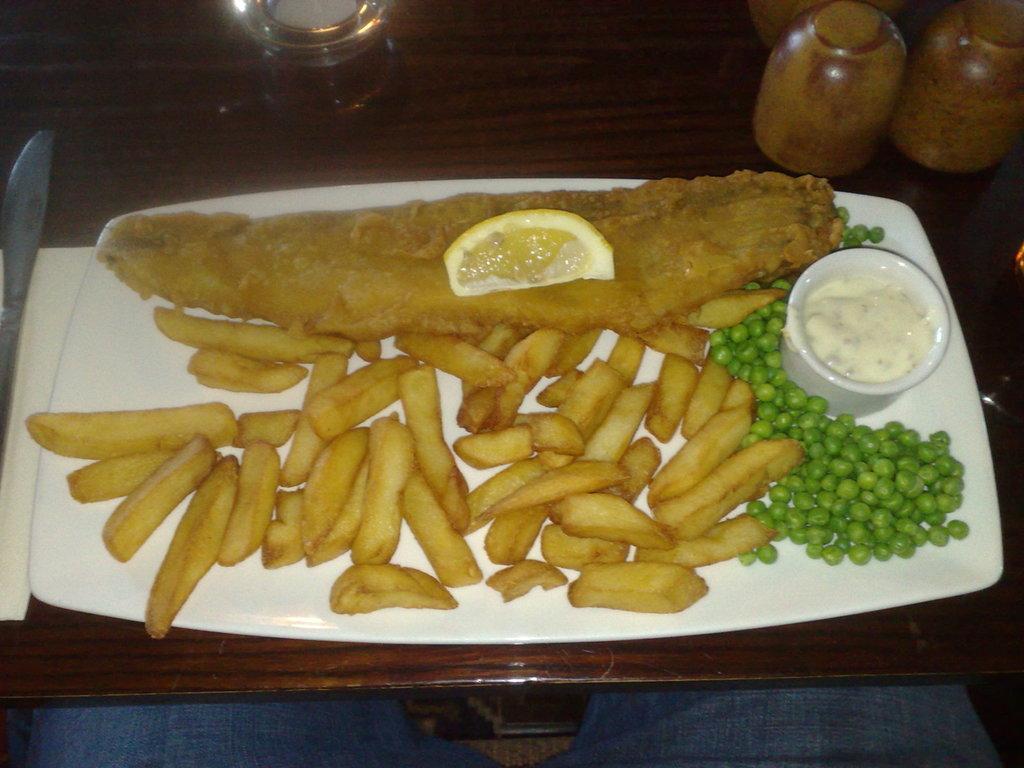How would you summarize this image in a sentence or two? In the image there are potato fries, lemon piece, sauce and boiled peas served on a white plate and kept on a table. 